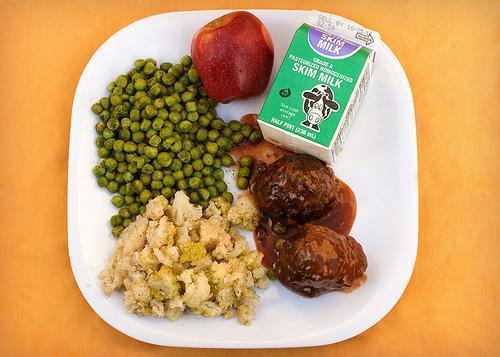How many meatballs are there?
Give a very brief answer. 2. 